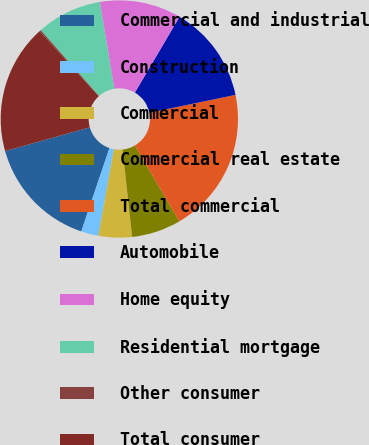<chart> <loc_0><loc_0><loc_500><loc_500><pie_chart><fcel>Commercial and industrial<fcel>Construction<fcel>Commercial<fcel>Commercial real estate<fcel>Total commercial<fcel>Automobile<fcel>Home equity<fcel>Residential mortgage<fcel>Other consumer<fcel>Total consumer<nl><fcel>15.45%<fcel>2.37%<fcel>4.55%<fcel>6.73%<fcel>19.81%<fcel>13.27%<fcel>11.09%<fcel>8.91%<fcel>0.19%<fcel>17.63%<nl></chart> 